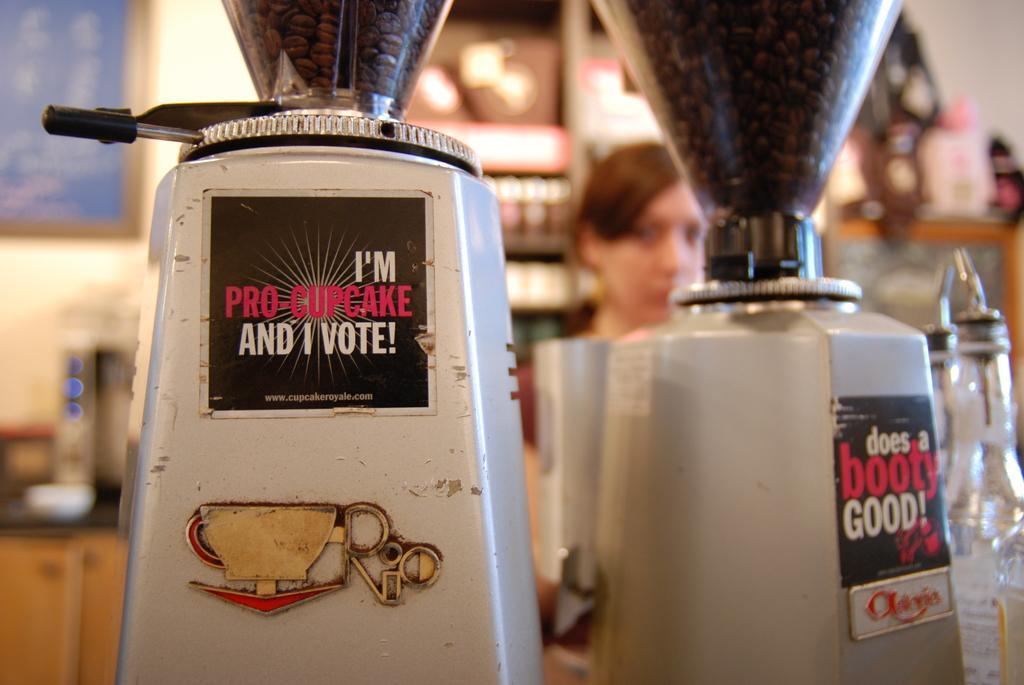Could you give a brief overview of what you see in this image? In this picture we can see machines, coffee beans, bottles, person and in the background we can see some objects and it is blurry. 